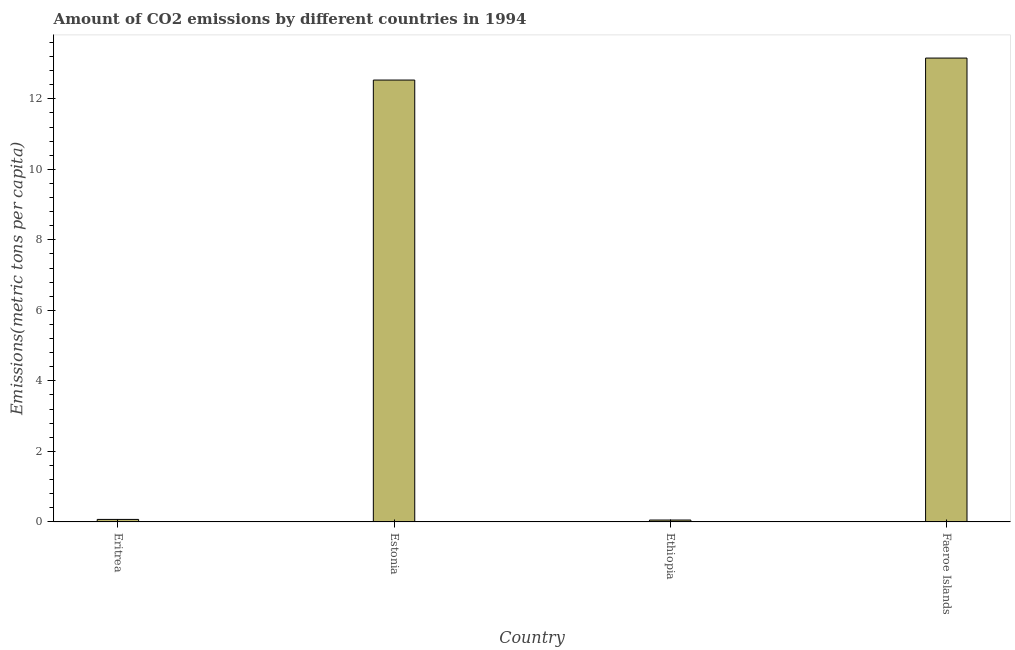What is the title of the graph?
Ensure brevity in your answer.  Amount of CO2 emissions by different countries in 1994. What is the label or title of the Y-axis?
Your answer should be very brief. Emissions(metric tons per capita). What is the amount of co2 emissions in Estonia?
Provide a short and direct response. 12.53. Across all countries, what is the maximum amount of co2 emissions?
Make the answer very short. 13.16. Across all countries, what is the minimum amount of co2 emissions?
Your response must be concise. 0.05. In which country was the amount of co2 emissions maximum?
Your response must be concise. Faeroe Islands. In which country was the amount of co2 emissions minimum?
Provide a short and direct response. Ethiopia. What is the sum of the amount of co2 emissions?
Make the answer very short. 25.81. What is the difference between the amount of co2 emissions in Estonia and Ethiopia?
Ensure brevity in your answer.  12.48. What is the average amount of co2 emissions per country?
Make the answer very short. 6.45. What is the median amount of co2 emissions?
Offer a very short reply. 6.3. In how many countries, is the amount of co2 emissions greater than 0.4 metric tons per capita?
Your answer should be compact. 2. What is the ratio of the amount of co2 emissions in Eritrea to that in Estonia?
Offer a very short reply. 0.01. Is the amount of co2 emissions in Eritrea less than that in Faeroe Islands?
Ensure brevity in your answer.  Yes. Is the difference between the amount of co2 emissions in Eritrea and Faeroe Islands greater than the difference between any two countries?
Your answer should be very brief. No. What is the difference between the highest and the second highest amount of co2 emissions?
Your answer should be compact. 0.62. Is the sum of the amount of co2 emissions in Estonia and Ethiopia greater than the maximum amount of co2 emissions across all countries?
Keep it short and to the point. No. What is the difference between the highest and the lowest amount of co2 emissions?
Your answer should be compact. 13.1. Are all the bars in the graph horizontal?
Offer a terse response. No. What is the difference between two consecutive major ticks on the Y-axis?
Offer a terse response. 2. What is the Emissions(metric tons per capita) in Eritrea?
Make the answer very short. 0.07. What is the Emissions(metric tons per capita) of Estonia?
Provide a succinct answer. 12.53. What is the Emissions(metric tons per capita) in Ethiopia?
Your response must be concise. 0.05. What is the Emissions(metric tons per capita) of Faeroe Islands?
Your answer should be very brief. 13.16. What is the difference between the Emissions(metric tons per capita) in Eritrea and Estonia?
Offer a terse response. -12.46. What is the difference between the Emissions(metric tons per capita) in Eritrea and Ethiopia?
Ensure brevity in your answer.  0.02. What is the difference between the Emissions(metric tons per capita) in Eritrea and Faeroe Islands?
Ensure brevity in your answer.  -13.08. What is the difference between the Emissions(metric tons per capita) in Estonia and Ethiopia?
Your answer should be compact. 12.48. What is the difference between the Emissions(metric tons per capita) in Estonia and Faeroe Islands?
Keep it short and to the point. -0.62. What is the difference between the Emissions(metric tons per capita) in Ethiopia and Faeroe Islands?
Your response must be concise. -13.1. What is the ratio of the Emissions(metric tons per capita) in Eritrea to that in Estonia?
Keep it short and to the point. 0.01. What is the ratio of the Emissions(metric tons per capita) in Eritrea to that in Ethiopia?
Give a very brief answer. 1.33. What is the ratio of the Emissions(metric tons per capita) in Eritrea to that in Faeroe Islands?
Your response must be concise. 0.01. What is the ratio of the Emissions(metric tons per capita) in Estonia to that in Ethiopia?
Give a very brief answer. 235.34. What is the ratio of the Emissions(metric tons per capita) in Estonia to that in Faeroe Islands?
Your answer should be very brief. 0.95. What is the ratio of the Emissions(metric tons per capita) in Ethiopia to that in Faeroe Islands?
Provide a short and direct response. 0. 